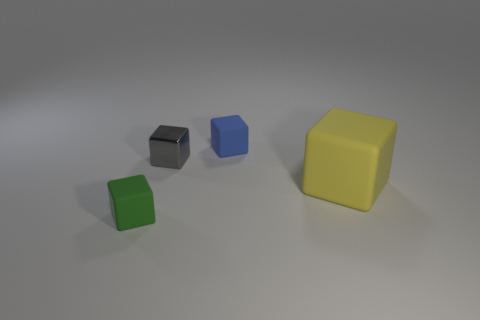The block that is both behind the yellow rubber object and right of the metallic thing is what color?
Make the answer very short. Blue. How many blue matte cubes are the same size as the yellow rubber block?
Ensure brevity in your answer.  0. The matte thing that is to the right of the small rubber object that is right of the green block is what shape?
Keep it short and to the point. Cube. There is a tiny rubber thing right of the cube in front of the matte block that is to the right of the blue matte cube; what is its shape?
Offer a terse response. Cube. How many big yellow things have the same shape as the gray shiny thing?
Your answer should be compact. 1. There is a matte block that is left of the tiny gray object; what number of tiny rubber things are in front of it?
Your response must be concise. 0. What number of matte things are small cubes or yellow cylinders?
Provide a short and direct response. 2. Is there a large cube that has the same material as the tiny blue object?
Provide a succinct answer. Yes. How many objects are either things that are on the left side of the yellow object or small cubes right of the green rubber object?
Your response must be concise. 3. Do the tiny matte object that is in front of the yellow matte cube and the shiny cube have the same color?
Provide a short and direct response. No. 